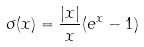Convert formula to latex. <formula><loc_0><loc_0><loc_500><loc_500>\sigma ( x ) = \frac { | x | } { x } ( e ^ { x } - 1 )</formula> 